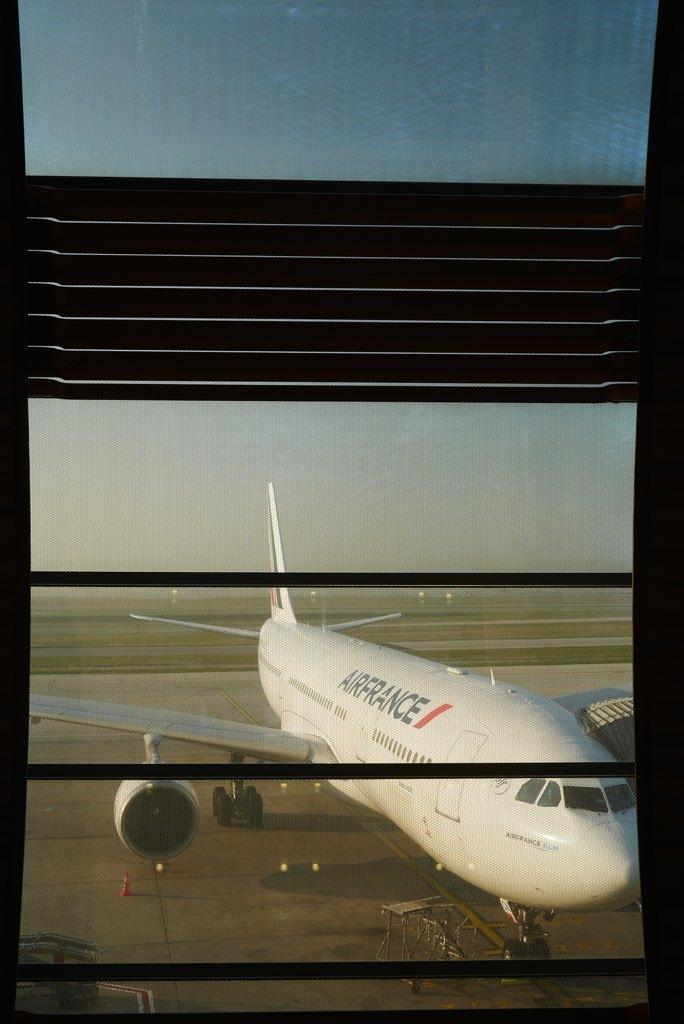<image>
Provide a brief description of the given image. The plane sitting at the airport is from AirFrance. 